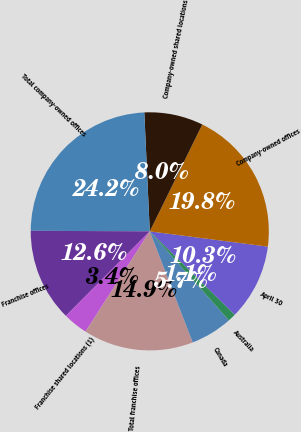Convert chart. <chart><loc_0><loc_0><loc_500><loc_500><pie_chart><fcel>April 30<fcel>Company-owned offices<fcel>Company-owned shared locations<fcel>Total company-owned offices<fcel>Franchise offices<fcel>Franchise shared locations (1)<fcel>Total franchise offices<fcel>Canada<fcel>Australia<nl><fcel>10.32%<fcel>19.78%<fcel>8.0%<fcel>24.19%<fcel>12.63%<fcel>3.38%<fcel>14.94%<fcel>5.69%<fcel>1.07%<nl></chart> 